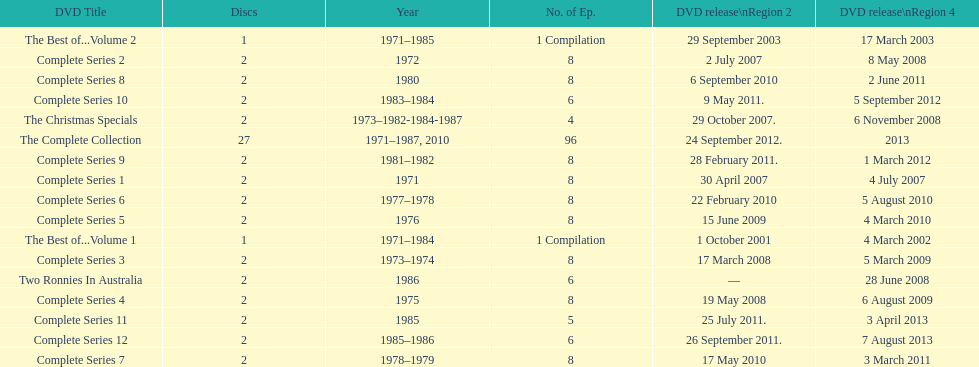What is previous to complete series 10? Complete Series 9. 